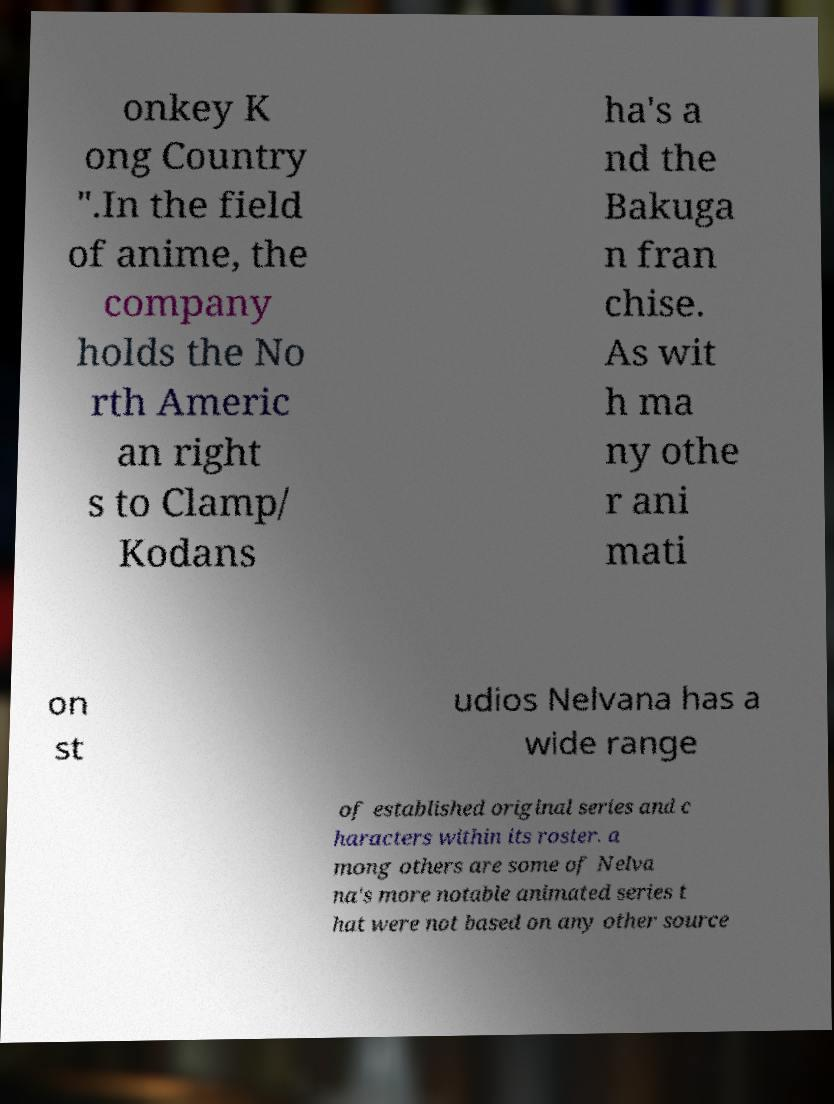Can you accurately transcribe the text from the provided image for me? onkey K ong Country ".In the field of anime, the company holds the No rth Americ an right s to Clamp/ Kodans ha's a nd the Bakuga n fran chise. As wit h ma ny othe r ani mati on st udios Nelvana has a wide range of established original series and c haracters within its roster. a mong others are some of Nelva na's more notable animated series t hat were not based on any other source 